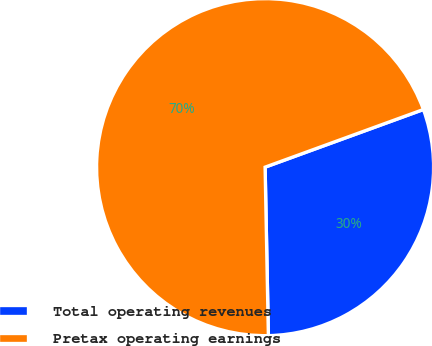Convert chart. <chart><loc_0><loc_0><loc_500><loc_500><pie_chart><fcel>Total operating revenues<fcel>Pretax operating earnings<nl><fcel>30.25%<fcel>69.75%<nl></chart> 